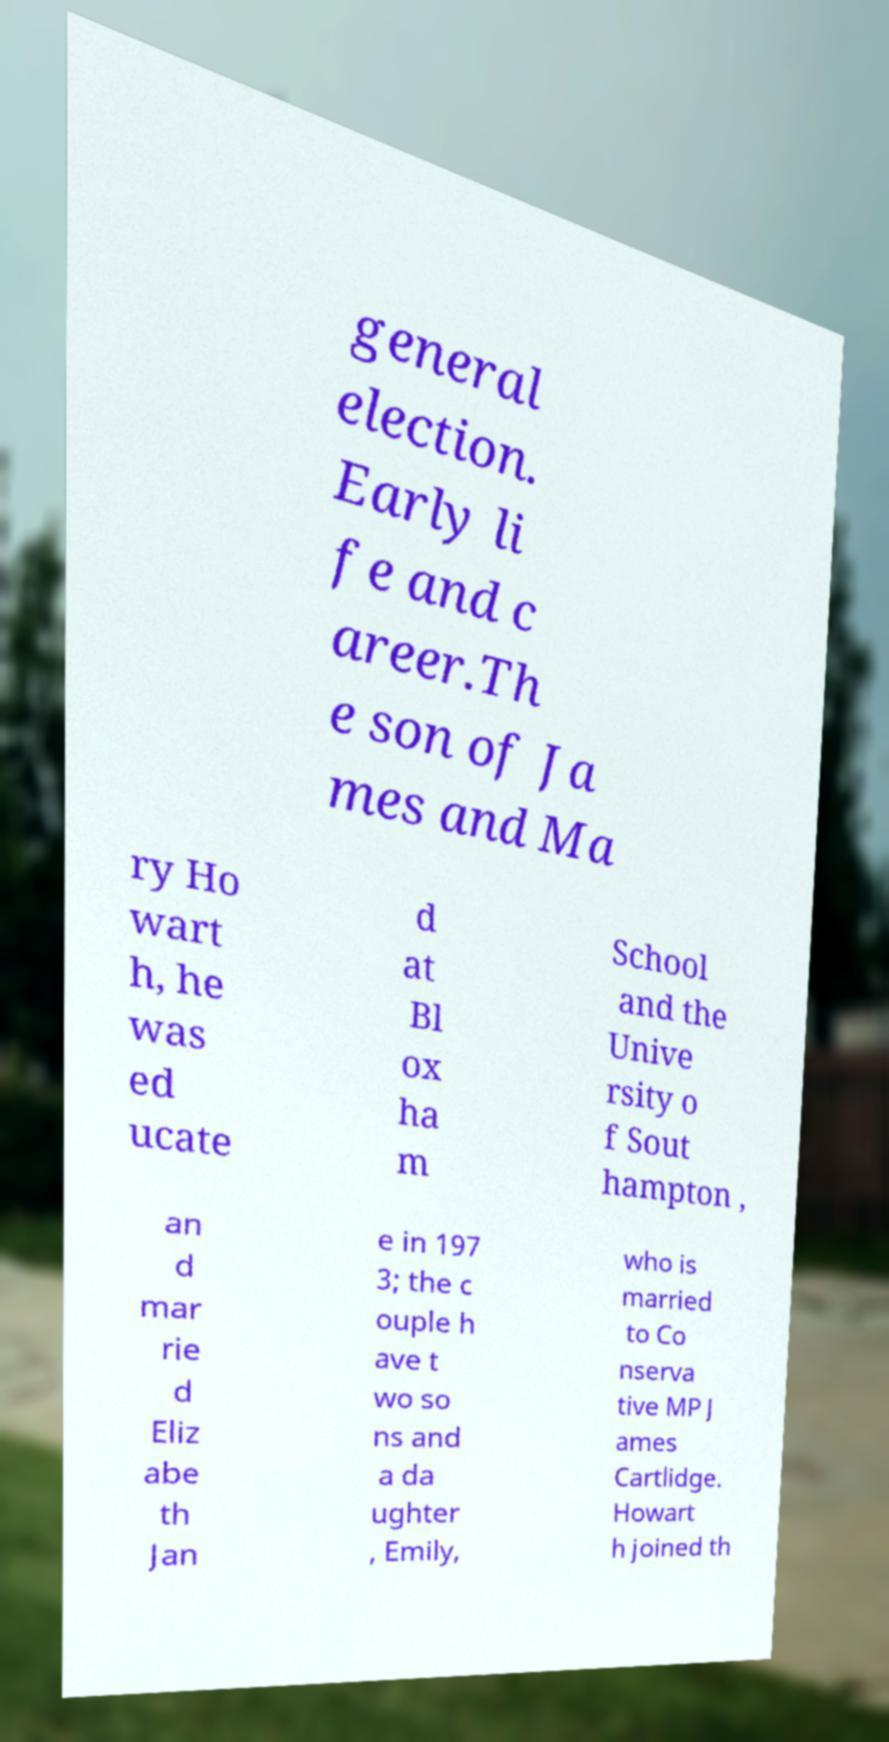What messages or text are displayed in this image? I need them in a readable, typed format. general election. Early li fe and c areer.Th e son of Ja mes and Ma ry Ho wart h, he was ed ucate d at Bl ox ha m School and the Unive rsity o f Sout hampton , an d mar rie d Eliz abe th Jan e in 197 3; the c ouple h ave t wo so ns and a da ughter , Emily, who is married to Co nserva tive MP J ames Cartlidge. Howart h joined th 